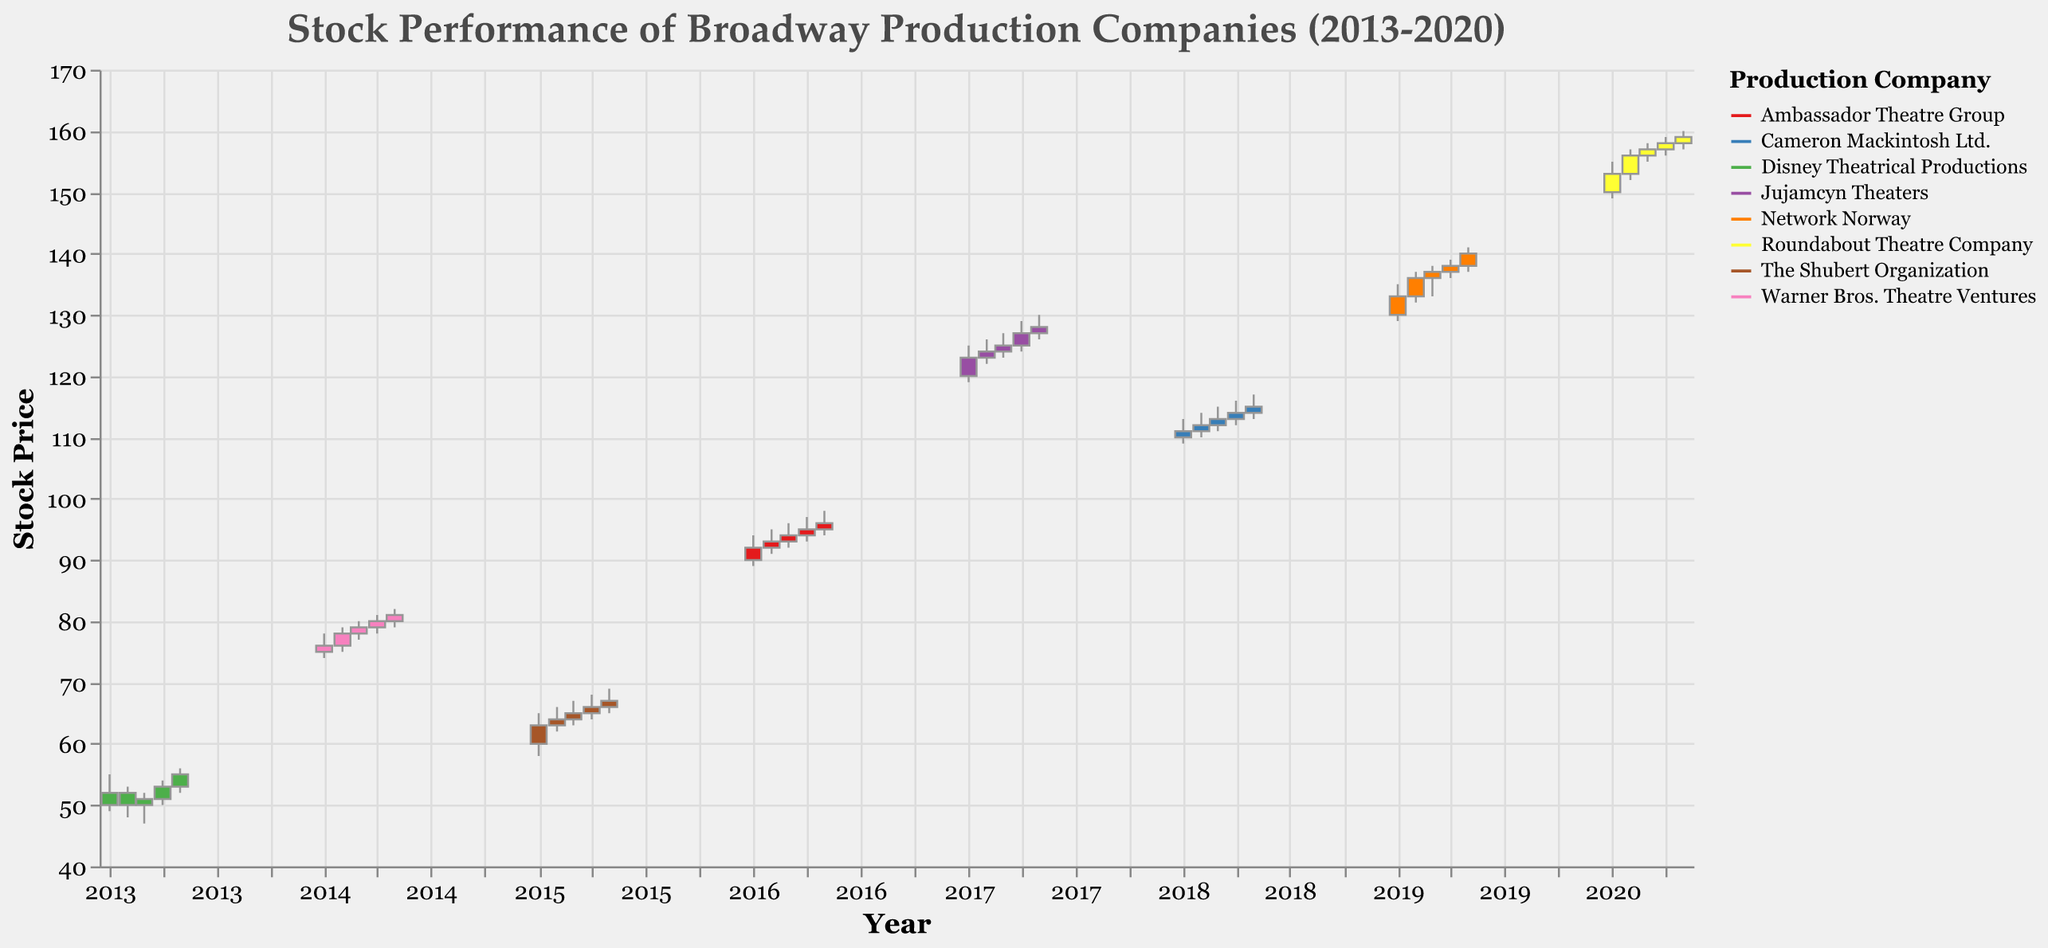How many different companies' stock performances are shown in the figure? By looking at the legend, we can count the number of different colors and labels representing the companies. There are 8 different companies listed.
Answer: 8 What is the highest closing stock price in the data and which company does it belong to? The highest closing price can be found by checking the "Close" values across all companies. The highest is from the Roundabout Theatre Company in 2020, with a closing price of 159.
Answer: 159, Roundabout Theatre Company Which company had the steepest price increase between two consecutive months and what was the increase? By examining the length of the bars and the changes between the open and close prices for consecutive months, the steepest increase is found between January and February 2019 for Network Norway, where the closing price increased from 133 to 136.
Answer: Network Norway, 3 Between which years did the Disney Theatrical Productions have an overall positive trend? By observing the overall direction from the first to the last data point of Disney Theatrical Productions, there is an overall positive trend from January 2013 to May 2013, where the closing price increased from 52 to 55.
Answer: Between January 2013 and May 2013 Did any company have consistent growth without any monthly decline? Which one? By checking the bar heights and close prices month to month, Ambassador Theatre Group shows consistent growth from January to May 2016.
Answer: Ambassador Theatre Group For which company was the monthly closing price the most stable relative to the high and low prices, and what indicates this? Monthly stability is indicated by shorter vertical lines (less variation between high and low prices). Jujamcyn Theaters, from January to May 2017, shows relatively short vertical lines.
Answer: Jujamcyn Theaters What's the combined closing price for Disney Theatrical Productions across the months shown? Summing up the closing prices for the given months: 52 + 50 + 51 + 53 + 55 = 261
Answer: 261 Which company experienced the highest stock price peak, and in which month did this occur? The highest peak can be determined by the "High" value. The Roundabout Theatre Company had the highest peak price of 160 in May 2020.
Answer: Roundabout Theatre Company, May 2020 How does the performance trend of Warner Bros. Theatre Ventures compare between the beginning and the end of the observation period? By comparing the first and last closing prices for Warner Bros. Theatre Ventures, they started at 76 and ended at 81, showing an increasing trend.
Answer: Increasing trend 